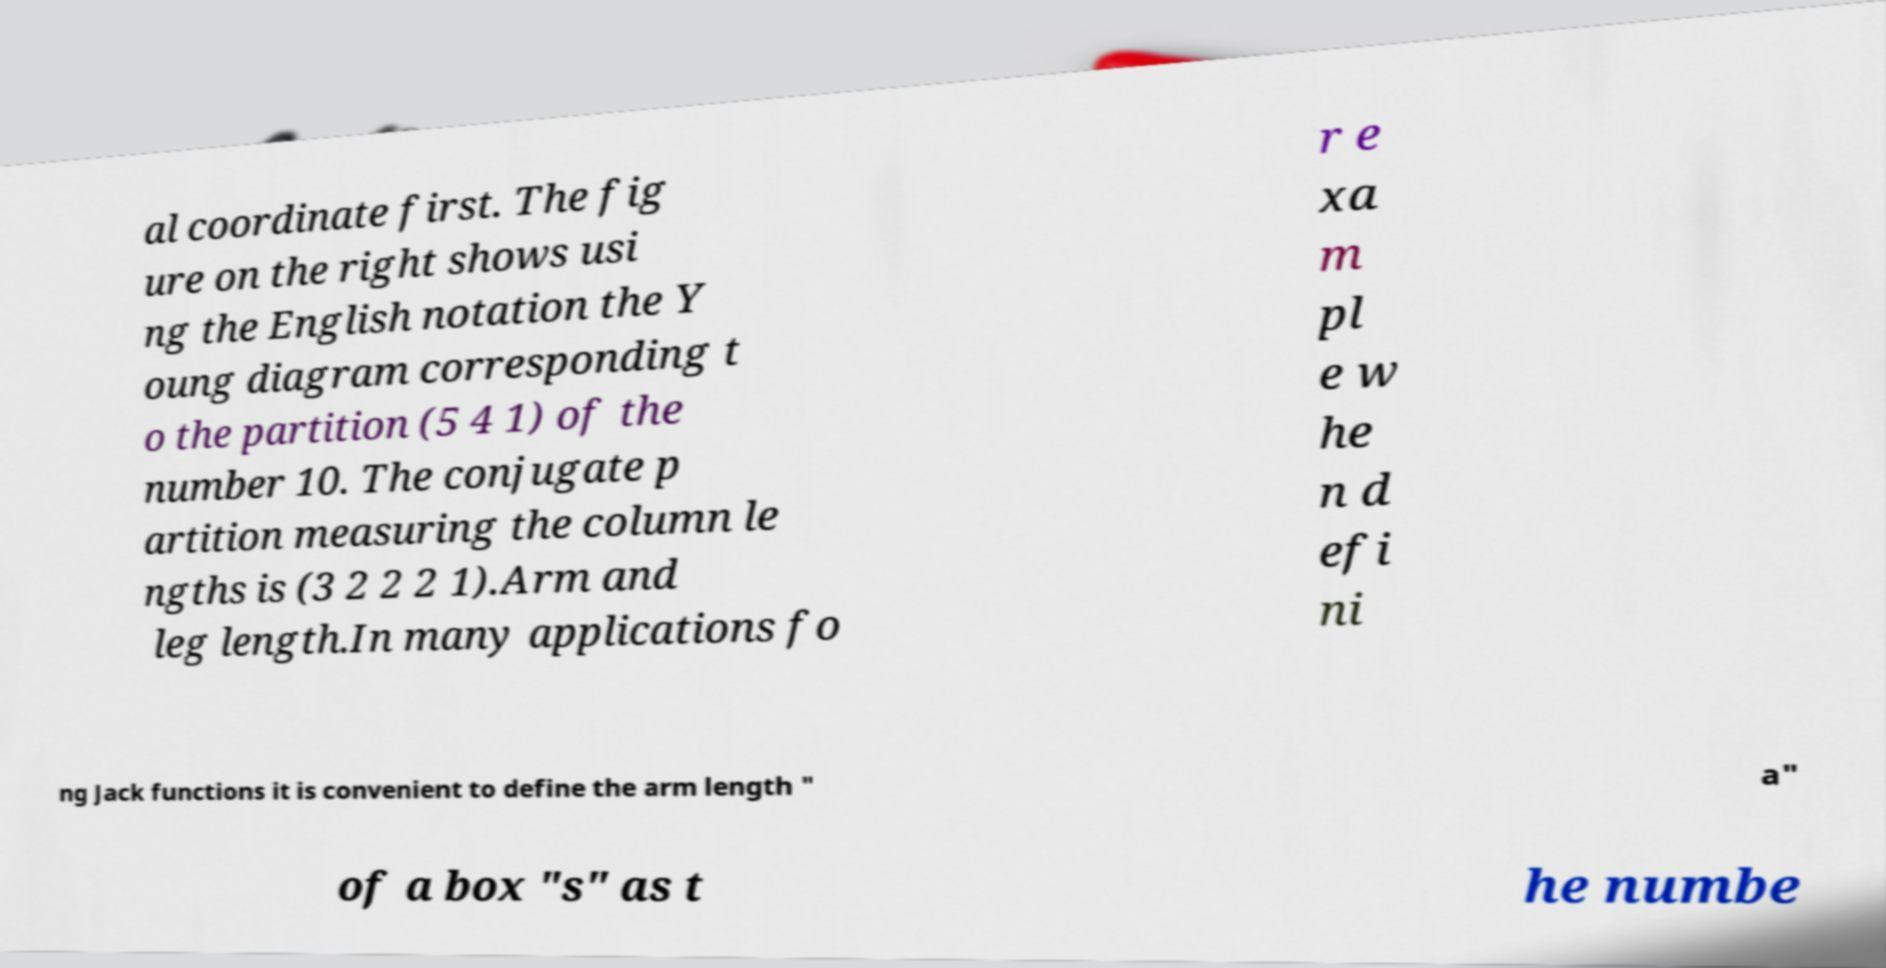Can you read and provide the text displayed in the image?This photo seems to have some interesting text. Can you extract and type it out for me? al coordinate first. The fig ure on the right shows usi ng the English notation the Y oung diagram corresponding t o the partition (5 4 1) of the number 10. The conjugate p artition measuring the column le ngths is (3 2 2 2 1).Arm and leg length.In many applications fo r e xa m pl e w he n d efi ni ng Jack functions it is convenient to define the arm length " a" of a box "s" as t he numbe 